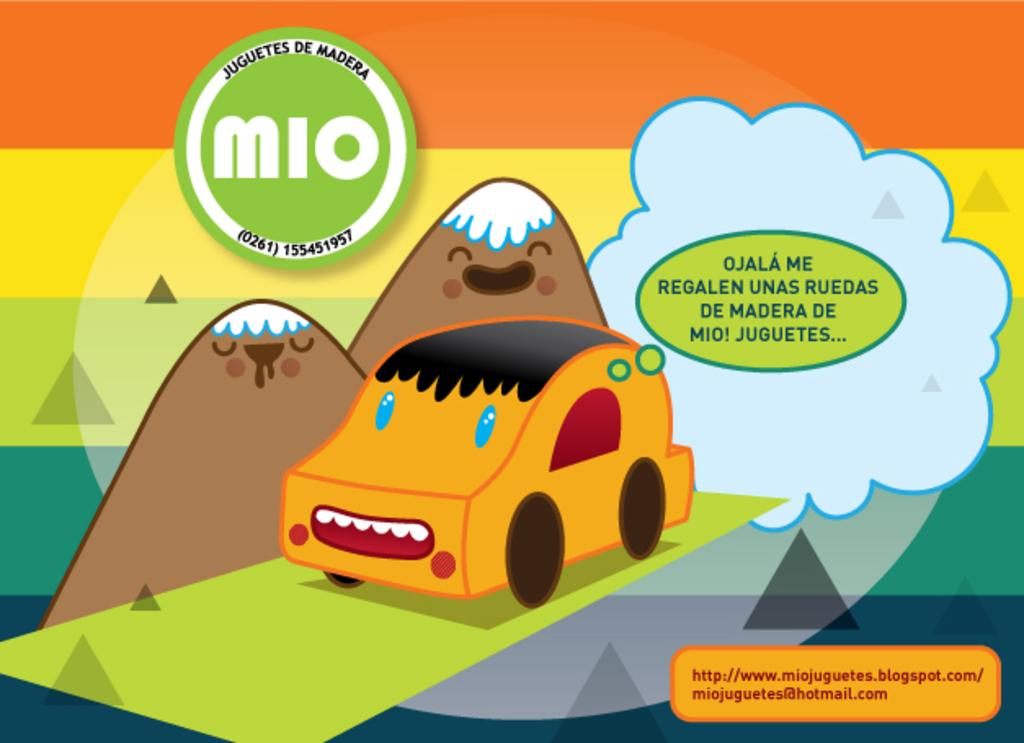What type of poster is in the image? There is a cartoon poster in the image. What is the main subject of the cartoon poster? The cartoon poster features a car. What type of landscape is depicted in the cartoon poster? There are mountains depicted in the cartoon poster. What else can be seen in the sky of the cartoon poster? There is a cloud in the cartoon poster. What color is the skirt worn by the car in the image? There is no skirt present in the image, as the main subject is a car in a cartoon poster. 